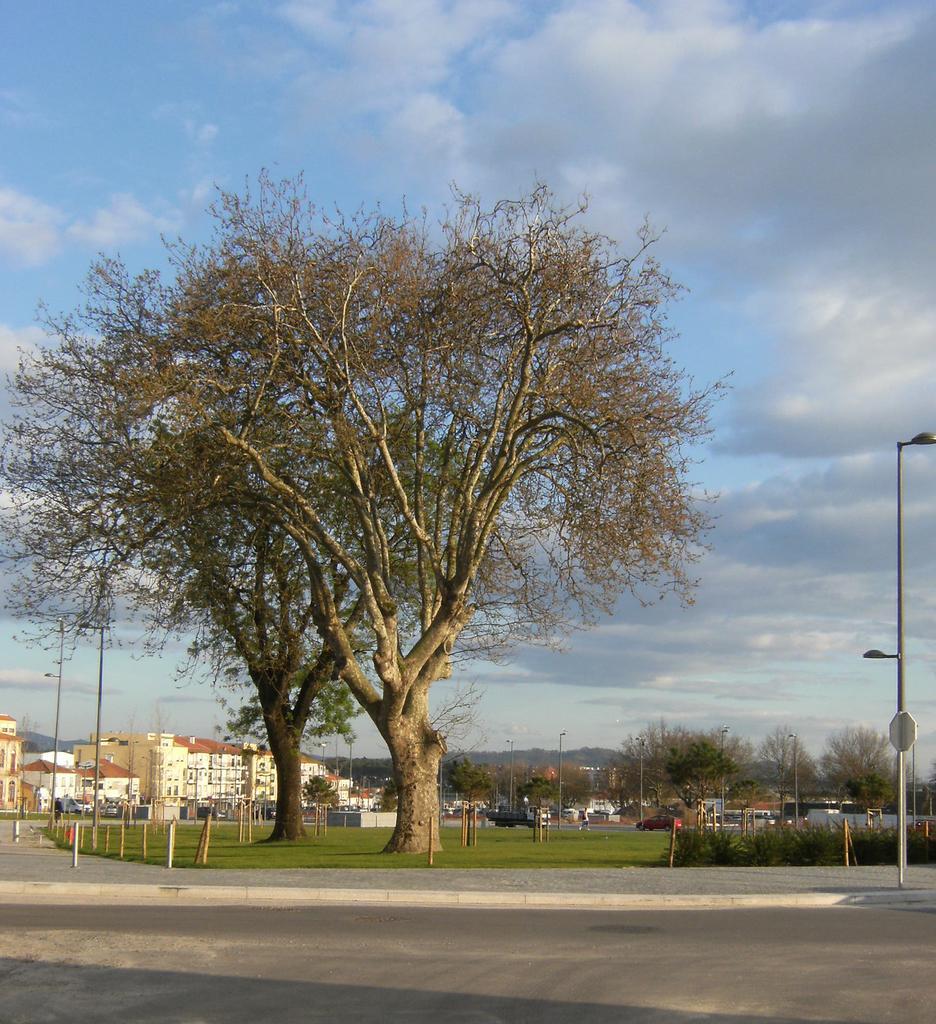In one or two sentences, can you explain what this image depicts? In the center of the image we can see two trees, group of poles. In the left side of the image we can see a group of buildings. In the background, we can see a truck parked on the road, a group of trees, mountain and cloudy sky. 